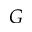Convert formula to latex. <formula><loc_0><loc_0><loc_500><loc_500>G</formula> 